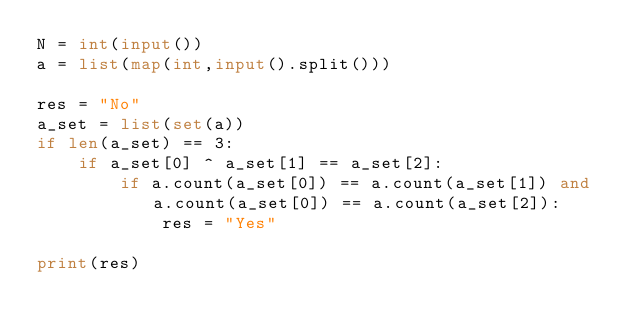<code> <loc_0><loc_0><loc_500><loc_500><_Python_>N = int(input())
a = list(map(int,input().split()))

res = "No"
a_set = list(set(a))
if len(a_set) == 3:
    if a_set[0] ^ a_set[1] == a_set[2]:
        if a.count(a_set[0]) == a.count(a_set[1]) and a.count(a_set[0]) == a.count(a_set[2]):
            res = "Yes"

print(res)</code> 